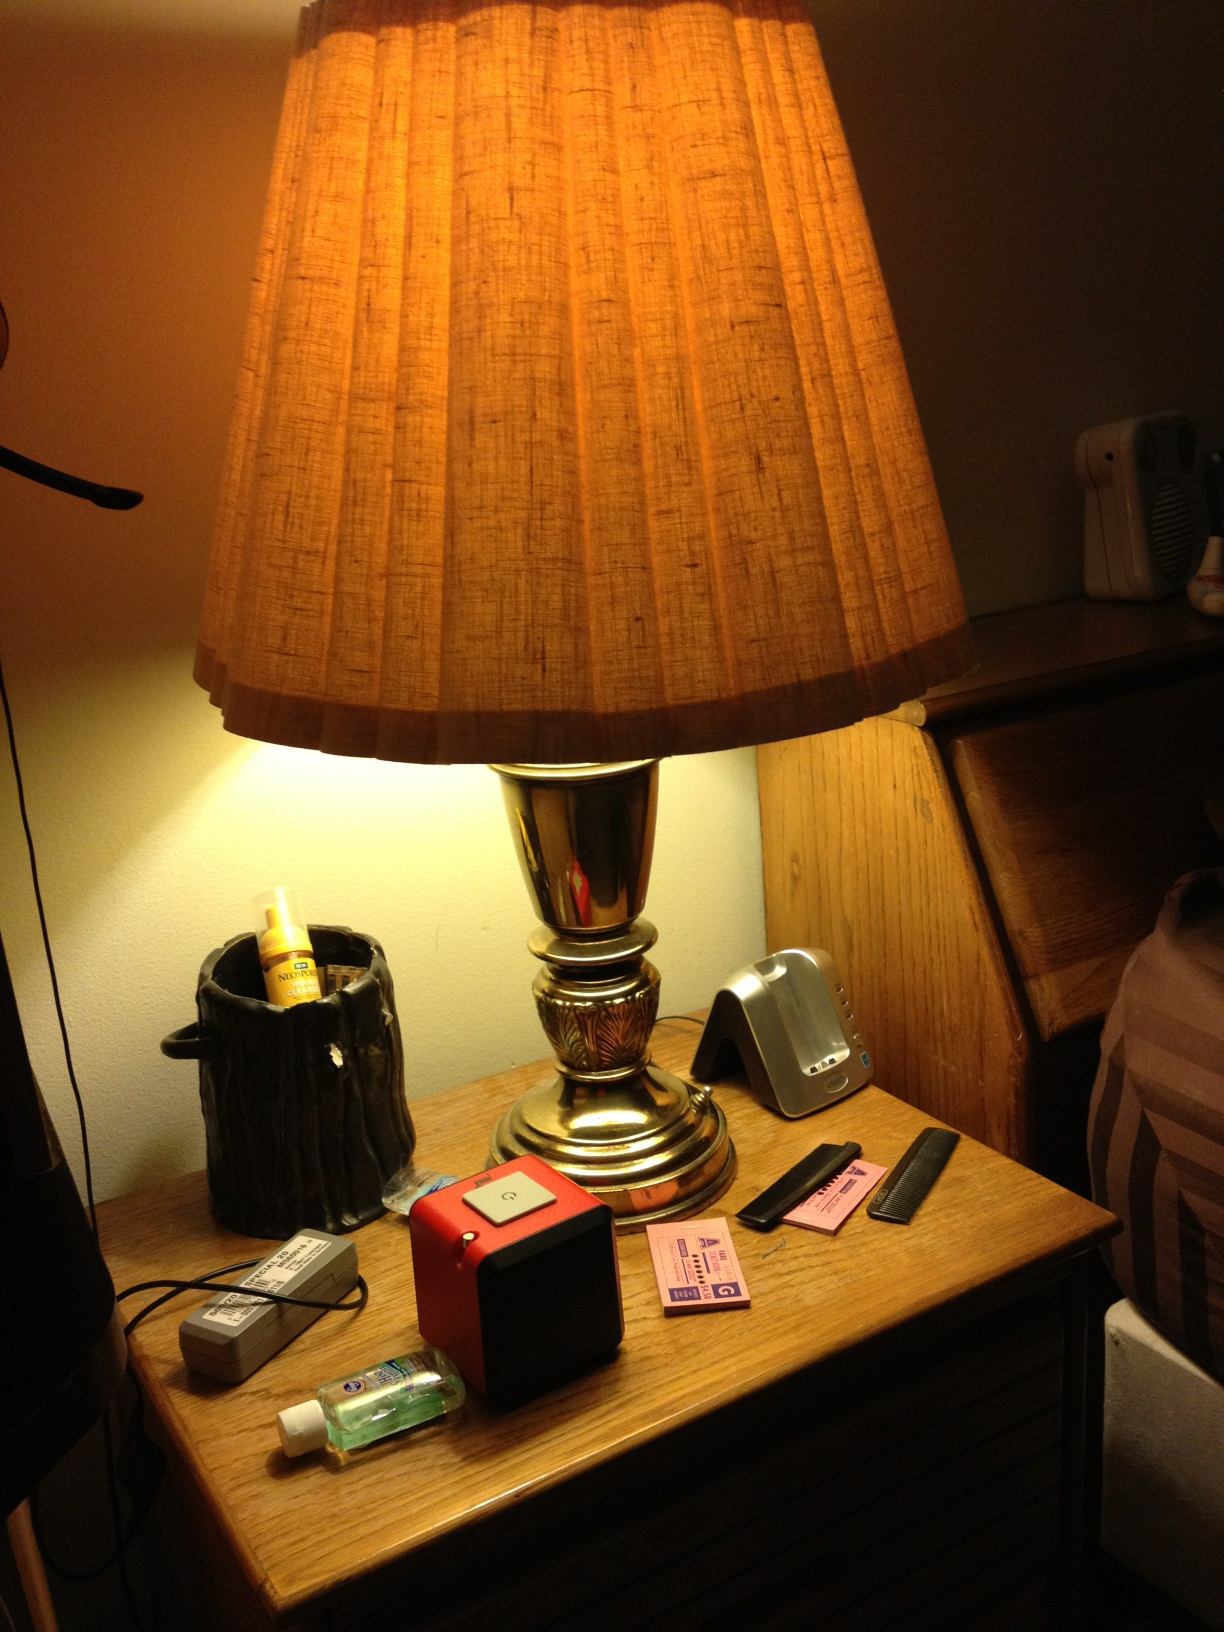Can you list all the items visible on the table next to the lamp? Certainly! The table next to the lamp features several items: a black ceramic holder with a yellow spray bottle inside it, a grey rectangular object with a cord, a small bottle of hand sanitizer, a red and black portable speaker, a stack of cards including what looks like a couple of ID cards, a metal stand possibly for a device, and a couple of combs. What might be the purpose of the metal stand on the table? The metal stand on the table is likely intended to hold a smartphone or a small tablet. Stands like this are often used to keep devices upright and accessible, making it easier to view or interact with them, especially when charging or using them as a clock or notification center. Imagine the lamp on the table is magical. What kind of powers could it possess? Imagine this lamp possesses magical powers bestowed by an ancient wizard. When switched on, it could envelop the room in a gentle, glowing aura that brings peace and tranquility to anyone within its light. Additionally, it might possess the ability to illuminate hidden secrets written in ancient texts, reveal invisible ink, or even open portals to other dimensions, allowing brief glimpses into alternate realities or worlds filled with fantastical creatures and landscapes! 